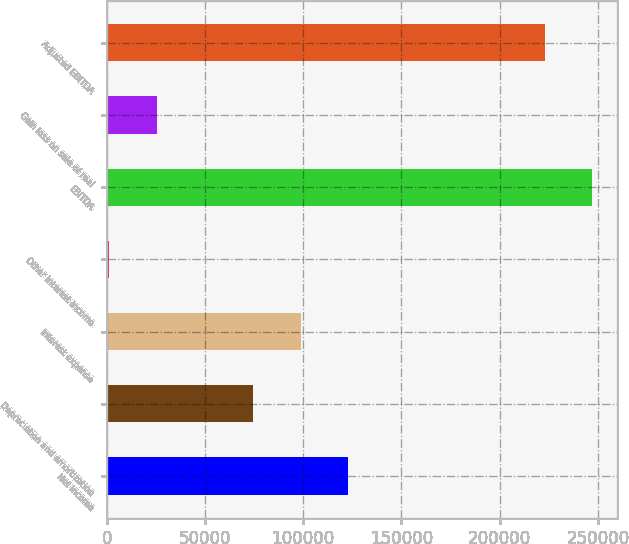Convert chart to OTSL. <chart><loc_0><loc_0><loc_500><loc_500><bar_chart><fcel>Net income<fcel>Depreciation and amortization<fcel>Interest expense<fcel>Other interest income<fcel>EBITDA<fcel>Gain loss on sale of real<fcel>Adjusted EBITDA<nl><fcel>122975<fcel>74616<fcel>98795.7<fcel>1274<fcel>247198<fcel>25453.7<fcel>223018<nl></chart> 